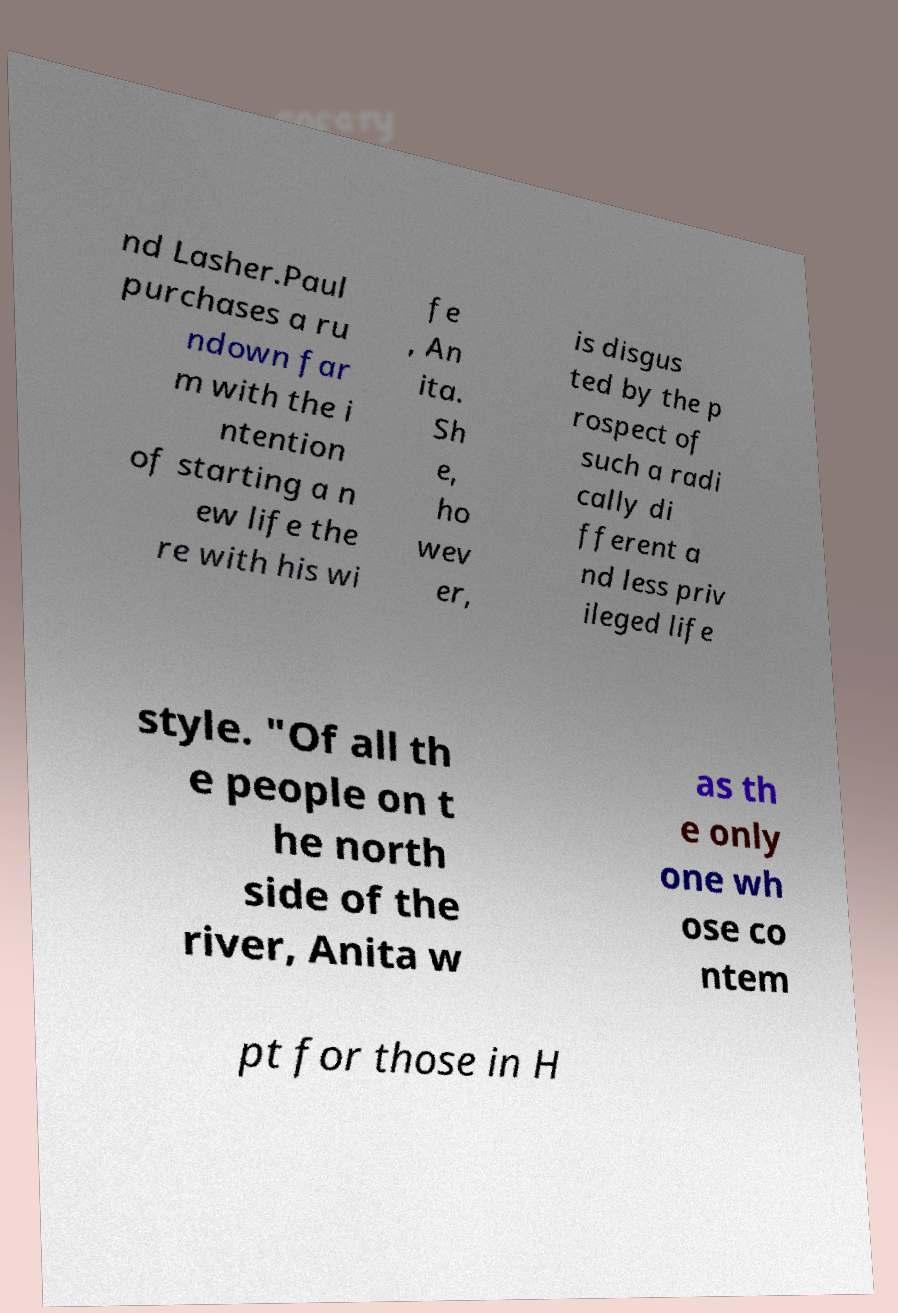Can you accurately transcribe the text from the provided image for me? nd Lasher.Paul purchases a ru ndown far m with the i ntention of starting a n ew life the re with his wi fe , An ita. Sh e, ho wev er, is disgus ted by the p rospect of such a radi cally di fferent a nd less priv ileged life style. "Of all th e people on t he north side of the river, Anita w as th e only one wh ose co ntem pt for those in H 